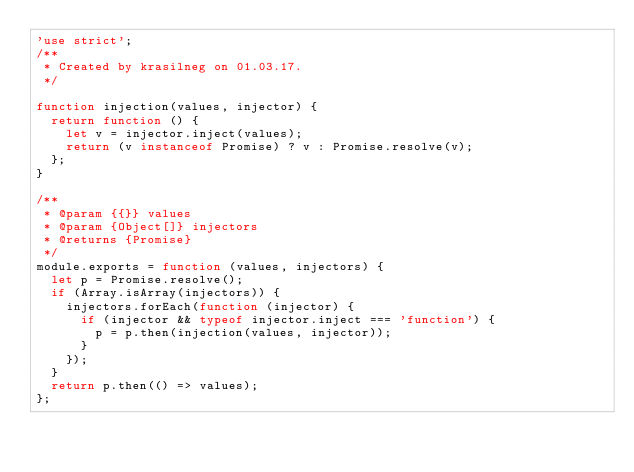<code> <loc_0><loc_0><loc_500><loc_500><_JavaScript_>'use strict';
/**
 * Created by krasilneg on 01.03.17.
 */

function injection(values, injector) {
  return function () {
    let v = injector.inject(values);
    return (v instanceof Promise) ? v : Promise.resolve(v);
  };
}

/**
 * @param {{}} values
 * @param {Object[]} injectors
 * @returns {Promise}
 */
module.exports = function (values, injectors) {
  let p = Promise.resolve();
  if (Array.isArray(injectors)) {
    injectors.forEach(function (injector) {
      if (injector && typeof injector.inject === 'function') {
        p = p.then(injection(values, injector));
      }
    });
  }
  return p.then(() => values);
};
</code> 